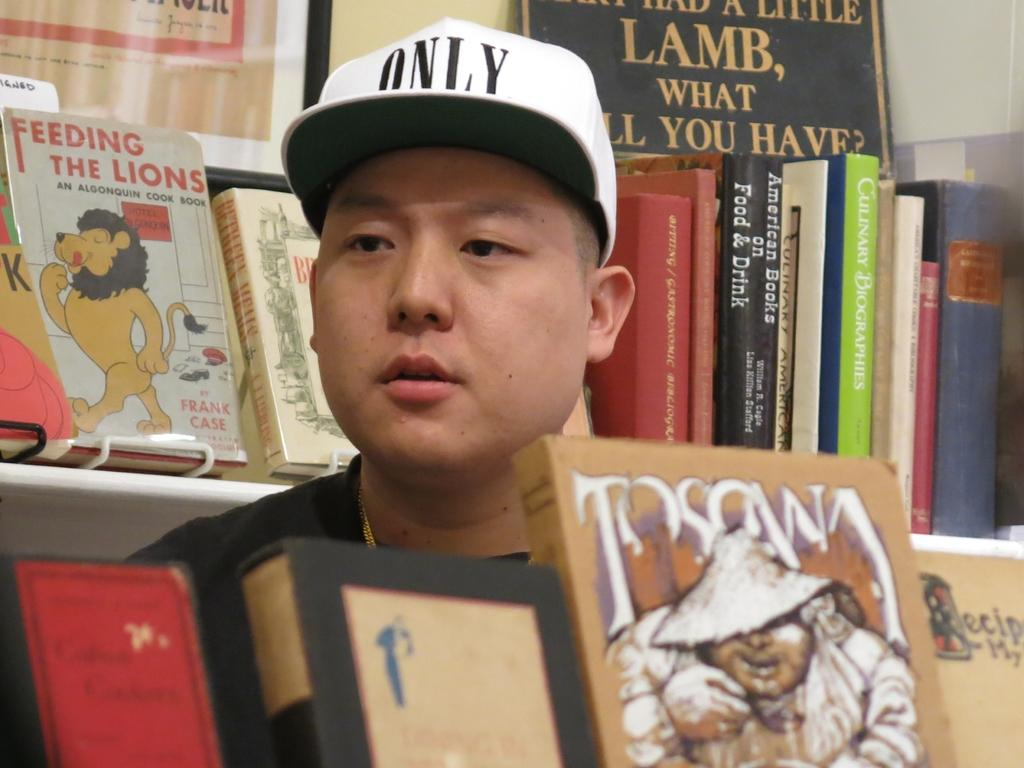<image>
Give a short and clear explanation of the subsequent image. A man wearing an "only" hat is sitting behind displayed books. 